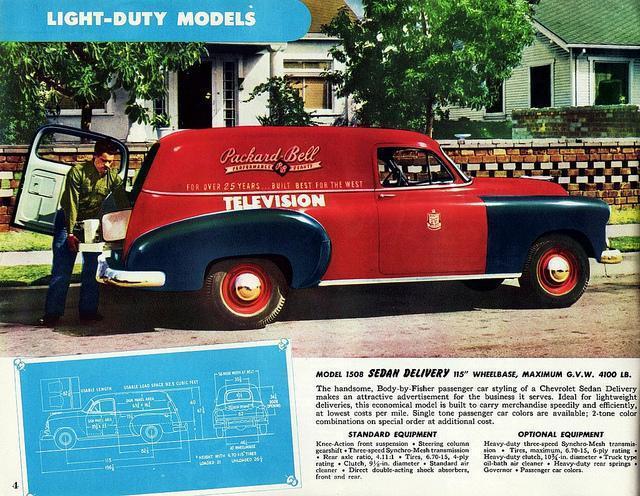How many people can be seen?
Give a very brief answer. 1. 